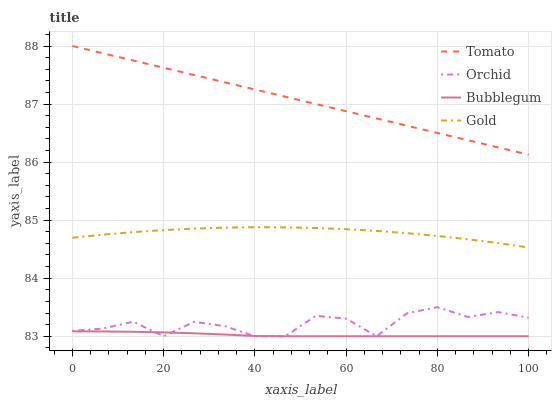Does Bubblegum have the minimum area under the curve?
Answer yes or no. Yes. Does Tomato have the maximum area under the curve?
Answer yes or no. Yes. Does Gold have the minimum area under the curve?
Answer yes or no. No. Does Gold have the maximum area under the curve?
Answer yes or no. No. Is Tomato the smoothest?
Answer yes or no. Yes. Is Orchid the roughest?
Answer yes or no. Yes. Is Gold the smoothest?
Answer yes or no. No. Is Gold the roughest?
Answer yes or no. No. Does Gold have the lowest value?
Answer yes or no. No. Does Gold have the highest value?
Answer yes or no. No. Is Orchid less than Tomato?
Answer yes or no. Yes. Is Gold greater than Bubblegum?
Answer yes or no. Yes. Does Orchid intersect Tomato?
Answer yes or no. No. 